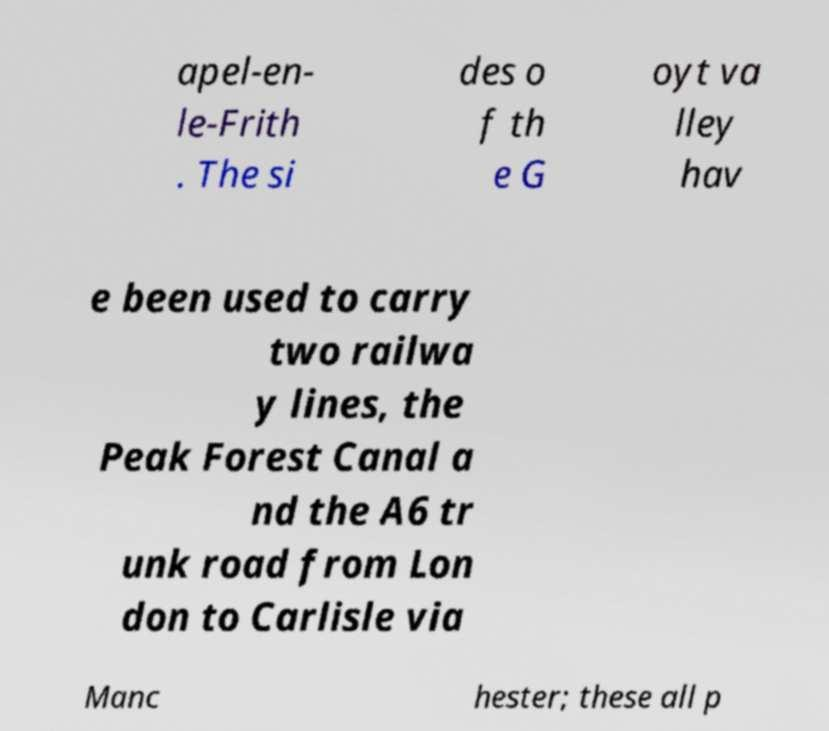I need the written content from this picture converted into text. Can you do that? apel-en- le-Frith . The si des o f th e G oyt va lley hav e been used to carry two railwa y lines, the Peak Forest Canal a nd the A6 tr unk road from Lon don to Carlisle via Manc hester; these all p 